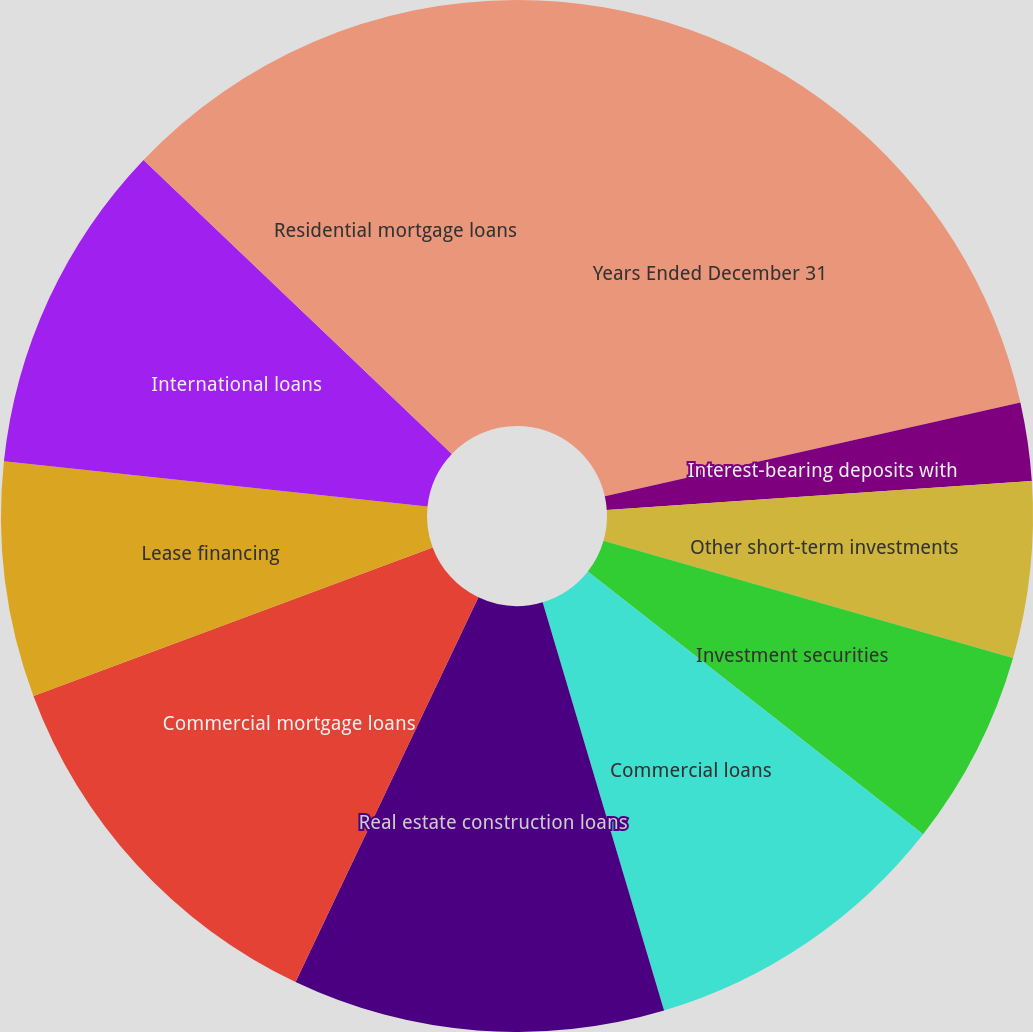<chart> <loc_0><loc_0><loc_500><loc_500><pie_chart><fcel>Years Ended December 31<fcel>Interest-bearing deposits with<fcel>Other short-term investments<fcel>Investment securities<fcel>Commercial loans<fcel>Real estate construction loans<fcel>Commercial mortgage loans<fcel>Lease financing<fcel>International loans<fcel>Residential mortgage loans<nl><fcel>21.47%<fcel>2.45%<fcel>5.52%<fcel>6.14%<fcel>9.82%<fcel>11.66%<fcel>12.27%<fcel>7.36%<fcel>10.43%<fcel>12.88%<nl></chart> 